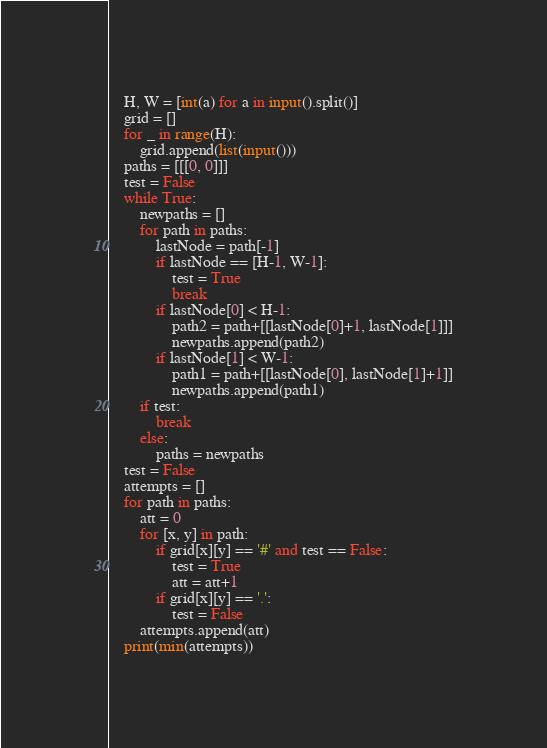Convert code to text. <code><loc_0><loc_0><loc_500><loc_500><_Python_>    H, W = [int(a) for a in input().split()]
    grid = []
    for _ in range(H):
        grid.append(list(input()))
    paths = [[[0, 0]]]
    test = False
    while True:
        newpaths = []
        for path in paths:
            lastNode = path[-1]
            if lastNode == [H-1, W-1]:
                test = True
                break
            if lastNode[0] < H-1:
                path2 = path+[[lastNode[0]+1, lastNode[1]]]
                newpaths.append(path2)
            if lastNode[1] < W-1:
                path1 = path+[[lastNode[0], lastNode[1]+1]]
                newpaths.append(path1)
        if test:
            break
        else:
            paths = newpaths
    test = False
    attempts = []
    for path in paths:
        att = 0
        for [x, y] in path:
            if grid[x][y] == '#' and test == False:
                test = True
                att = att+1
            if grid[x][y] == '.':
                test = False
        attempts.append(att)
    print(min(attempts))</code> 